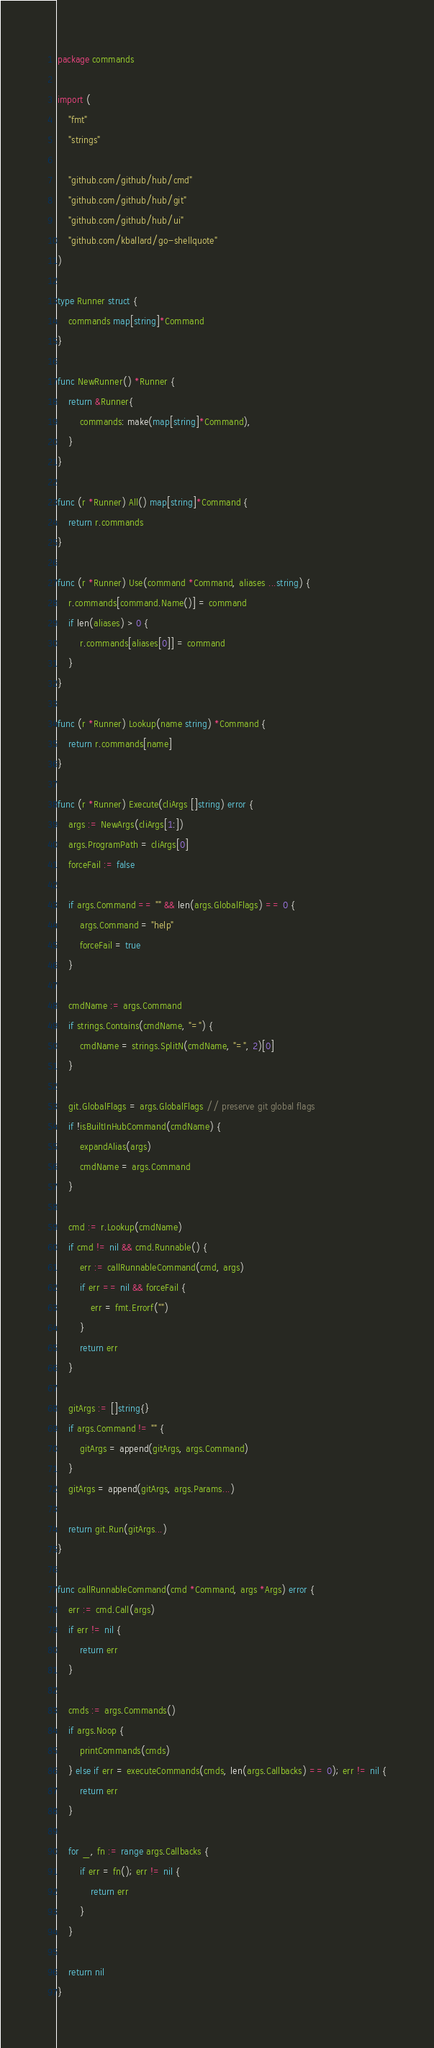<code> <loc_0><loc_0><loc_500><loc_500><_Go_>package commands

import (
	"fmt"
	"strings"

	"github.com/github/hub/cmd"
	"github.com/github/hub/git"
	"github.com/github/hub/ui"
	"github.com/kballard/go-shellquote"
)

type Runner struct {
	commands map[string]*Command
}

func NewRunner() *Runner {
	return &Runner{
		commands: make(map[string]*Command),
	}
}

func (r *Runner) All() map[string]*Command {
	return r.commands
}

func (r *Runner) Use(command *Command, aliases ...string) {
	r.commands[command.Name()] = command
	if len(aliases) > 0 {
		r.commands[aliases[0]] = command
	}
}

func (r *Runner) Lookup(name string) *Command {
	return r.commands[name]
}

func (r *Runner) Execute(cliArgs []string) error {
	args := NewArgs(cliArgs[1:])
	args.ProgramPath = cliArgs[0]
	forceFail := false

	if args.Command == "" && len(args.GlobalFlags) == 0 {
		args.Command = "help"
		forceFail = true
	}

	cmdName := args.Command
	if strings.Contains(cmdName, "=") {
		cmdName = strings.SplitN(cmdName, "=", 2)[0]
	}

	git.GlobalFlags = args.GlobalFlags // preserve git global flags
	if !isBuiltInHubCommand(cmdName) {
		expandAlias(args)
		cmdName = args.Command
	}

	cmd := r.Lookup(cmdName)
	if cmd != nil && cmd.Runnable() {
		err := callRunnableCommand(cmd, args)
		if err == nil && forceFail {
			err = fmt.Errorf("")
		}
		return err
	}

	gitArgs := []string{}
	if args.Command != "" {
		gitArgs = append(gitArgs, args.Command)
	}
	gitArgs = append(gitArgs, args.Params...)

	return git.Run(gitArgs...)
}

func callRunnableCommand(cmd *Command, args *Args) error {
	err := cmd.Call(args)
	if err != nil {
		return err
	}

	cmds := args.Commands()
	if args.Noop {
		printCommands(cmds)
	} else if err = executeCommands(cmds, len(args.Callbacks) == 0); err != nil {
		return err
	}

	for _, fn := range args.Callbacks {
		if err = fn(); err != nil {
			return err
		}
	}

	return nil
}
</code> 